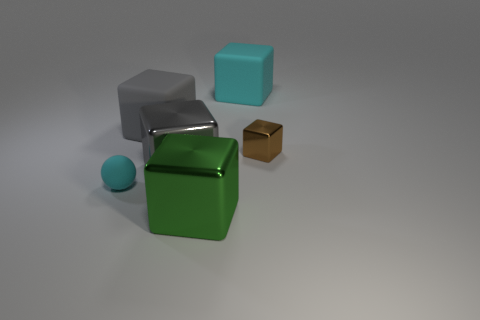Subtract 1 blocks. How many blocks are left? 4 Subtract all blue blocks. Subtract all brown cylinders. How many blocks are left? 5 Add 3 big green shiny things. How many objects exist? 9 Subtract all balls. How many objects are left? 5 Subtract 0 gray spheres. How many objects are left? 6 Subtract all matte objects. Subtract all brown metallic objects. How many objects are left? 2 Add 2 gray metallic things. How many gray metallic things are left? 3 Add 2 matte cubes. How many matte cubes exist? 4 